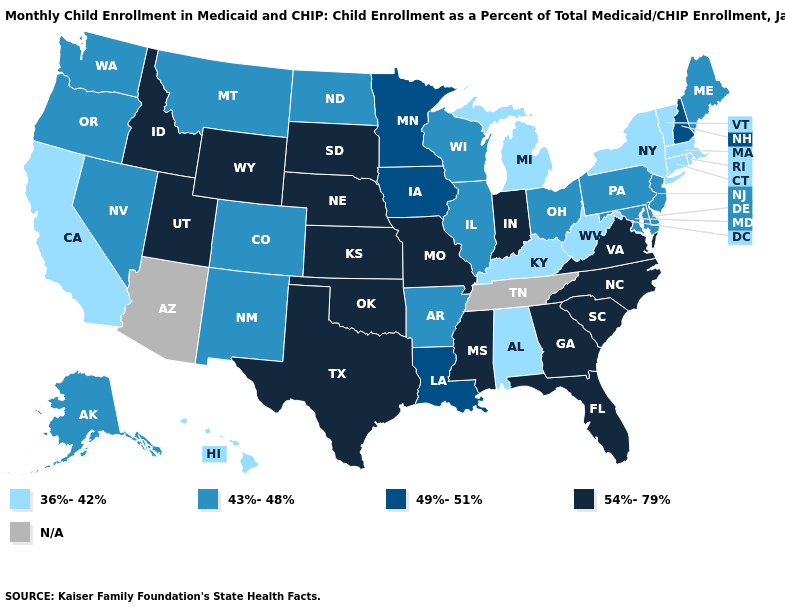Does Michigan have the lowest value in the MidWest?
Quick response, please. Yes. What is the highest value in states that border Nebraska?
Be succinct. 54%-79%. Does Nebraska have the highest value in the MidWest?
Be succinct. Yes. Name the states that have a value in the range 49%-51%?
Be succinct. Iowa, Louisiana, Minnesota, New Hampshire. Does the map have missing data?
Keep it brief. Yes. Name the states that have a value in the range 54%-79%?
Be succinct. Florida, Georgia, Idaho, Indiana, Kansas, Mississippi, Missouri, Nebraska, North Carolina, Oklahoma, South Carolina, South Dakota, Texas, Utah, Virginia, Wyoming. Which states have the lowest value in the USA?
Keep it brief. Alabama, California, Connecticut, Hawaii, Kentucky, Massachusetts, Michigan, New York, Rhode Island, Vermont, West Virginia. What is the highest value in states that border Iowa?
Keep it brief. 54%-79%. What is the value of Arizona?
Quick response, please. N/A. What is the lowest value in states that border North Dakota?
Quick response, please. 43%-48%. Name the states that have a value in the range 36%-42%?
Concise answer only. Alabama, California, Connecticut, Hawaii, Kentucky, Massachusetts, Michigan, New York, Rhode Island, Vermont, West Virginia. 